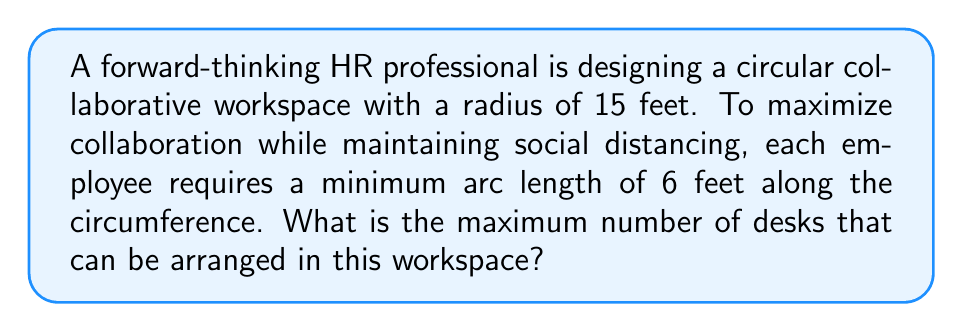Teach me how to tackle this problem. Let's approach this step-by-step:

1) First, we need to calculate the circumference of the circular workspace:
   $$C = 2\pi r$$
   where $C$ is the circumference and $r$ is the radius.

2) Given $r = 15$ feet, we can calculate:
   $$C = 2\pi(15) = 30\pi \approx 94.25 \text{ feet}$$

3) Each employee requires a minimum arc length of 6 feet. This means we need to determine how many 6-foot segments can fit along the circumference.

4) We can calculate this by dividing the total circumference by the required arc length per desk:
   $$\text{Number of desks} = \frac{\text{Circumference}}{\text{Arc length per desk}}$$

5) Substituting our values:
   $$\text{Number of desks} = \frac{30\pi}{6} = 5\pi \approx 15.71$$

6) Since we can't have a fractional number of desks, we need to round down to the nearest whole number.

[asy]
import geometry;

size(200);
draw(circle((0,0),15), blue);
for(int i=0; i<15; ++i) {
  dot(15*dir(i*24), red);
}
label("15 ft", (0,0)--(15,0), N);
[/asy]
Answer: 15 desks 